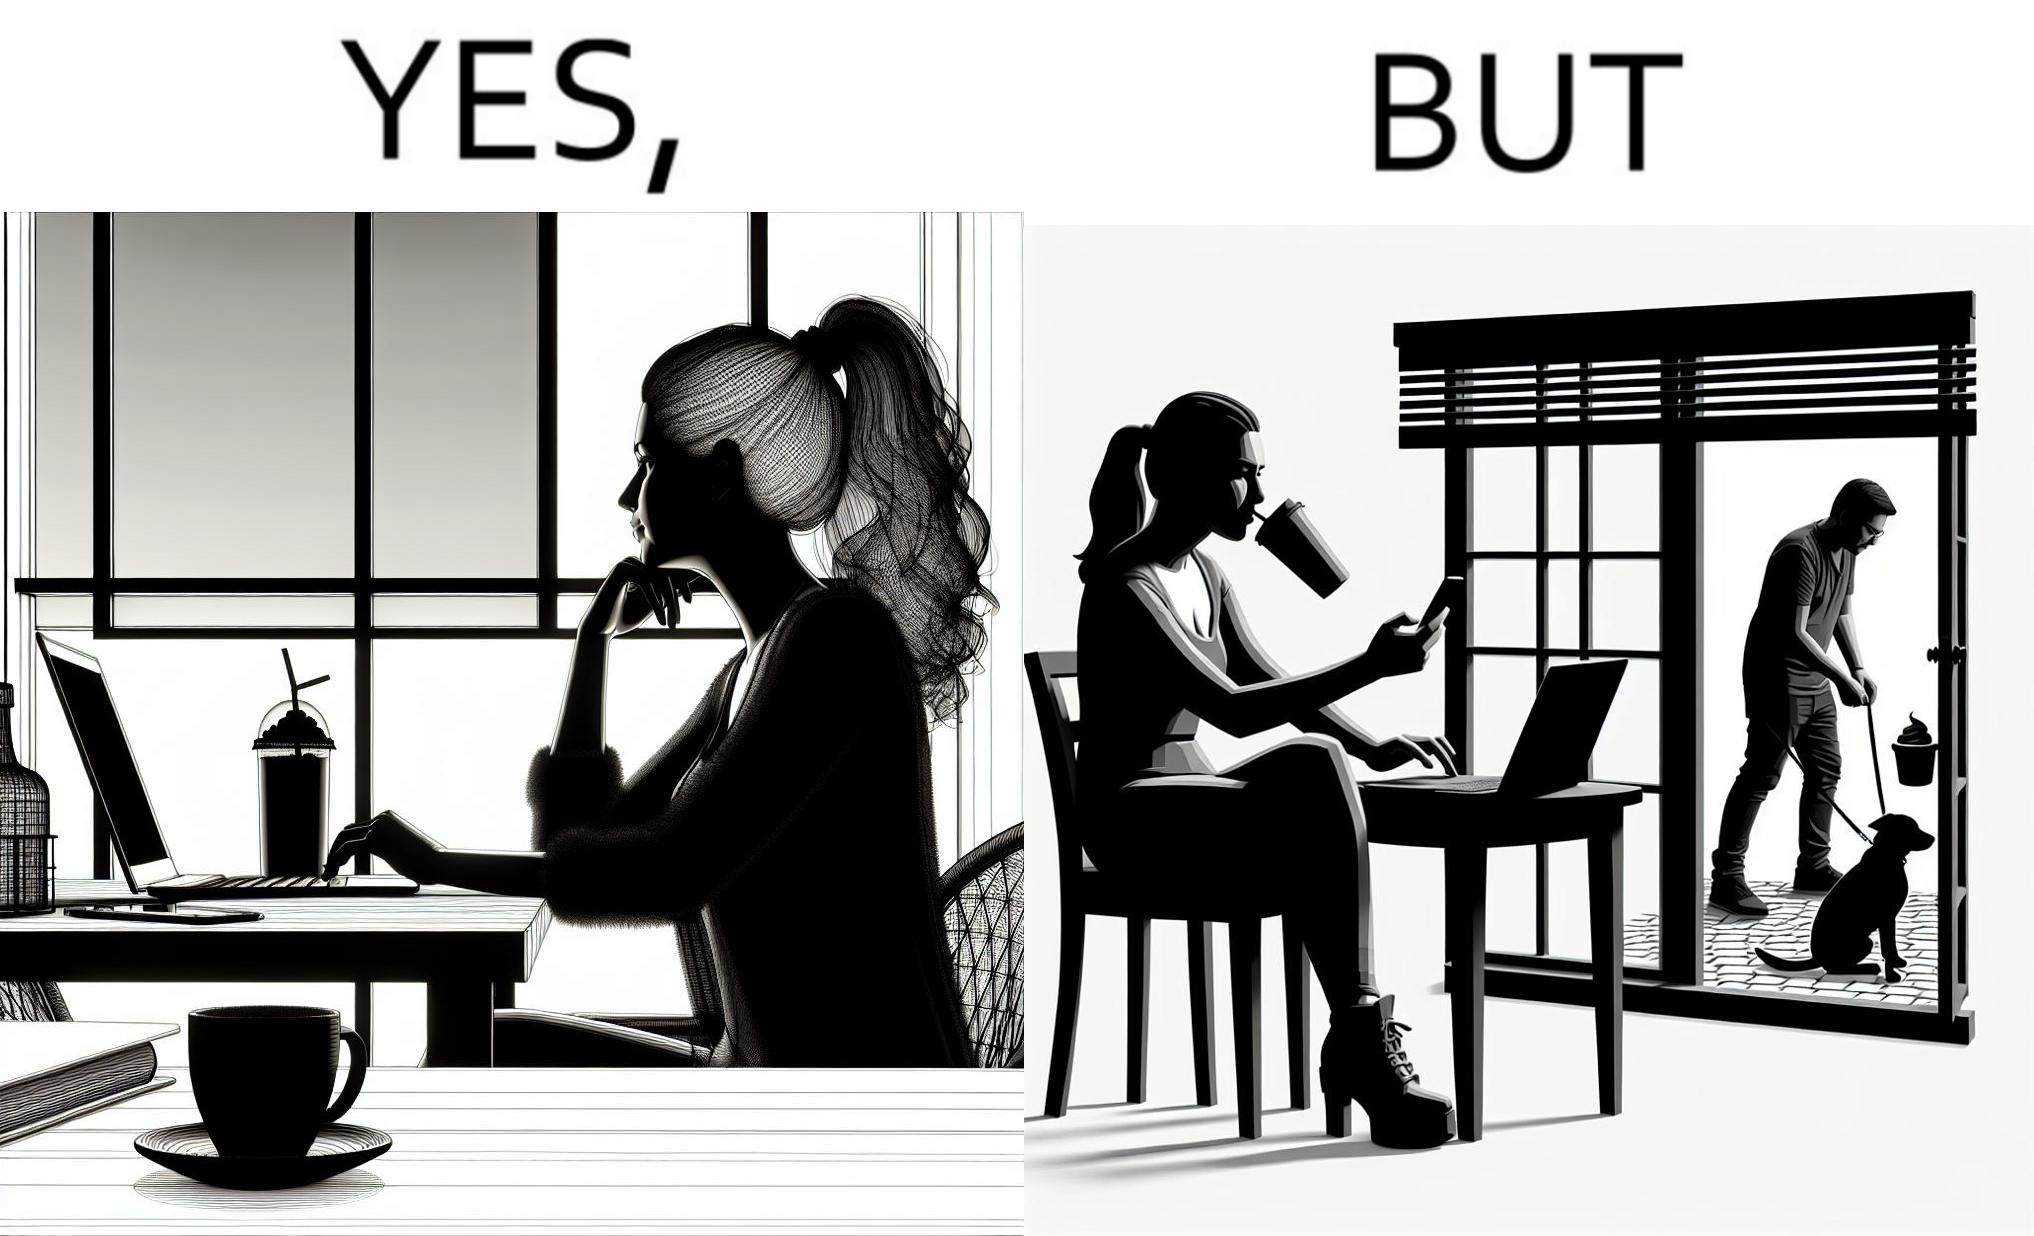Is this a satirical image? Yes, this image is satirical. 